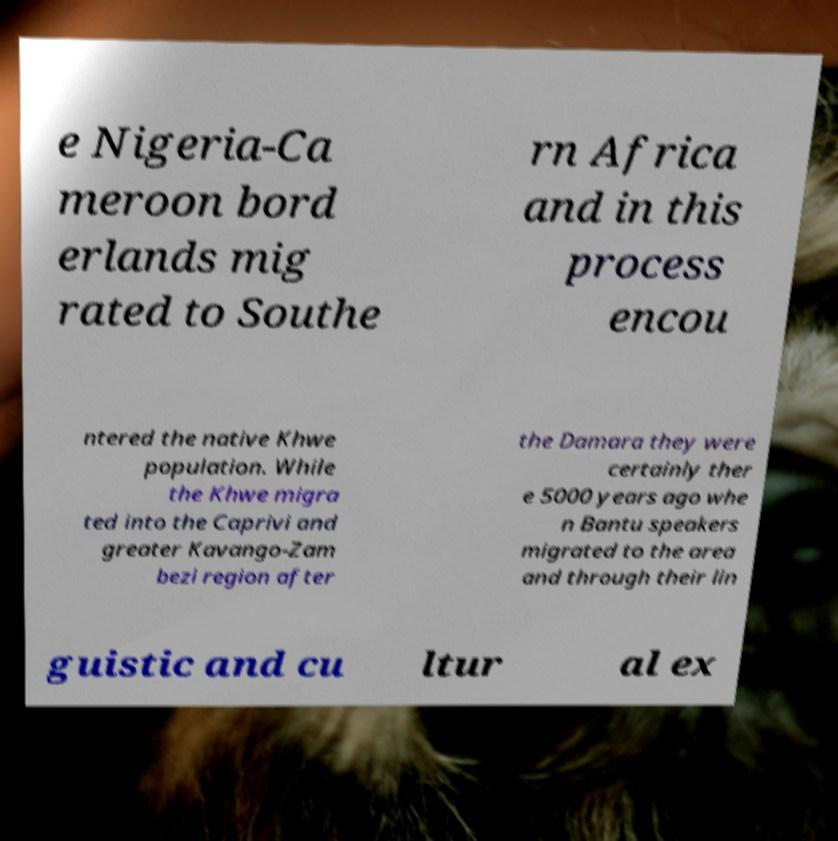Could you assist in decoding the text presented in this image and type it out clearly? e Nigeria-Ca meroon bord erlands mig rated to Southe rn Africa and in this process encou ntered the native Khwe population. While the Khwe migra ted into the Caprivi and greater Kavango-Zam bezi region after the Damara they were certainly ther e 5000 years ago whe n Bantu speakers migrated to the area and through their lin guistic and cu ltur al ex 